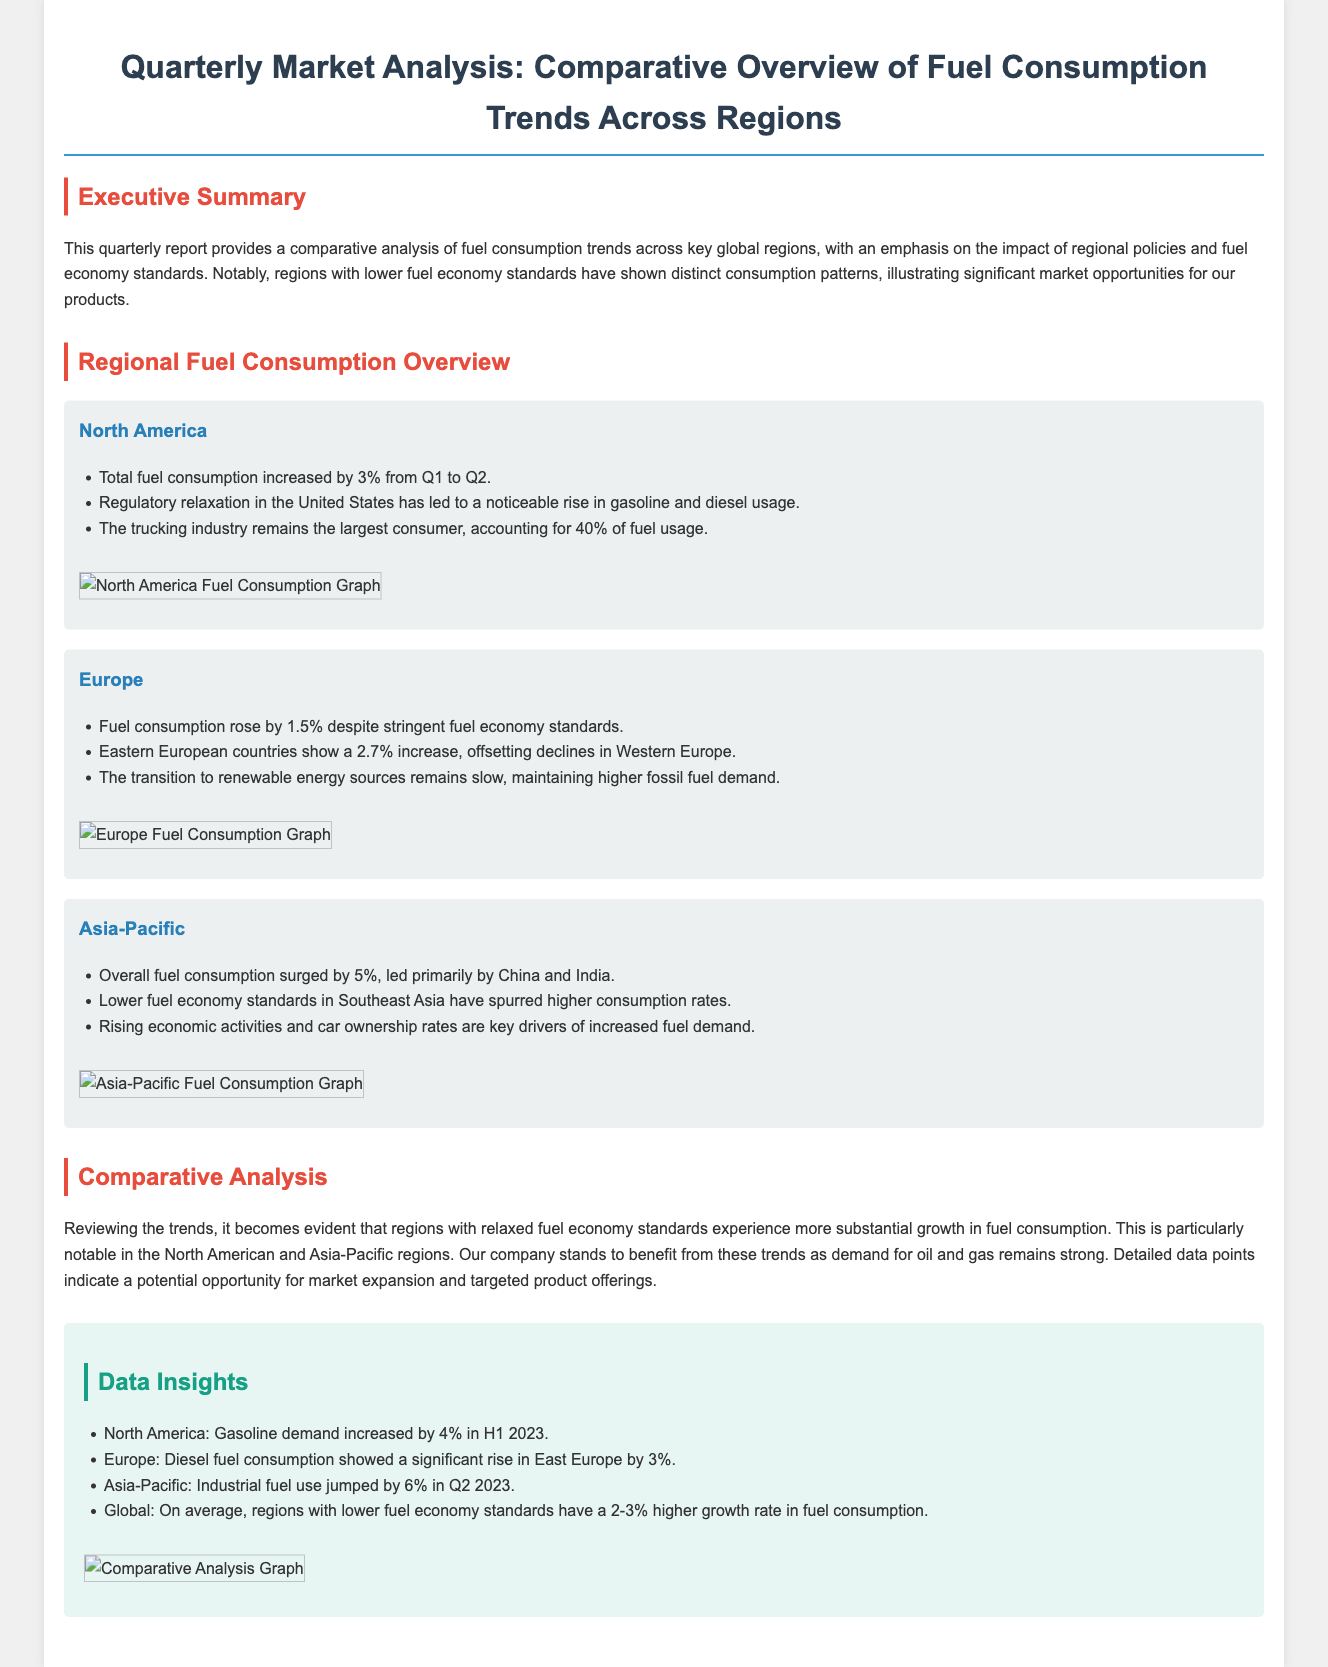What is the percentage increase in North America's fuel consumption from Q1 to Q2? The document states that total fuel consumption in North America increased by 3% from Q1 to Q2.
Answer: 3% Which region shows a 2.7% increase in fuel consumption? In the document, it's mentioned that Eastern European countries show a 2.7% increase in fuel consumption.
Answer: Eastern Europe What sector accounts for 40% of fuel usage in North America? The document highlights that the trucking industry remains the largest consumer, accounting for 40% of fuel usage.
Answer: Trucking industry What is the rise in industrial fuel use in Asia-Pacific during Q2 2023? According to the data insights, industrial fuel use jumped by 6% in the Asia-Pacific region in Q2 2023.
Answer: 6% What is the key factor driving increased fuel demand in Asia-Pacific? The document points out that rising economic activities and car ownership rates are key drivers of increased fuel demand in this region.
Answer: Economic activities and car ownership rates What is the average growth rate in fuel consumption for regions with lower fuel economy standards? The data insights state that regions with lower fuel economy standards have a 2-3% higher growth rate in fuel consumption on average.
Answer: 2-3% Which region has experienced a rise in diesel fuel consumption by 3%? The document mentions that diesel fuel consumption showed a significant rise in East Europe by 3%.
Answer: East Europe What is the total fuel consumption increase for Europe? The document states that fuel consumption rose by 1.5% in Europe despite stringent fuel economy standards.
Answer: 1.5% What does the report emphasize regarding regulatory policies? The report emphasizes the impact of regional policies and fuel economy standards on fuel consumption trends across regions.
Answer: Impact of regional policies and fuel economy standards 